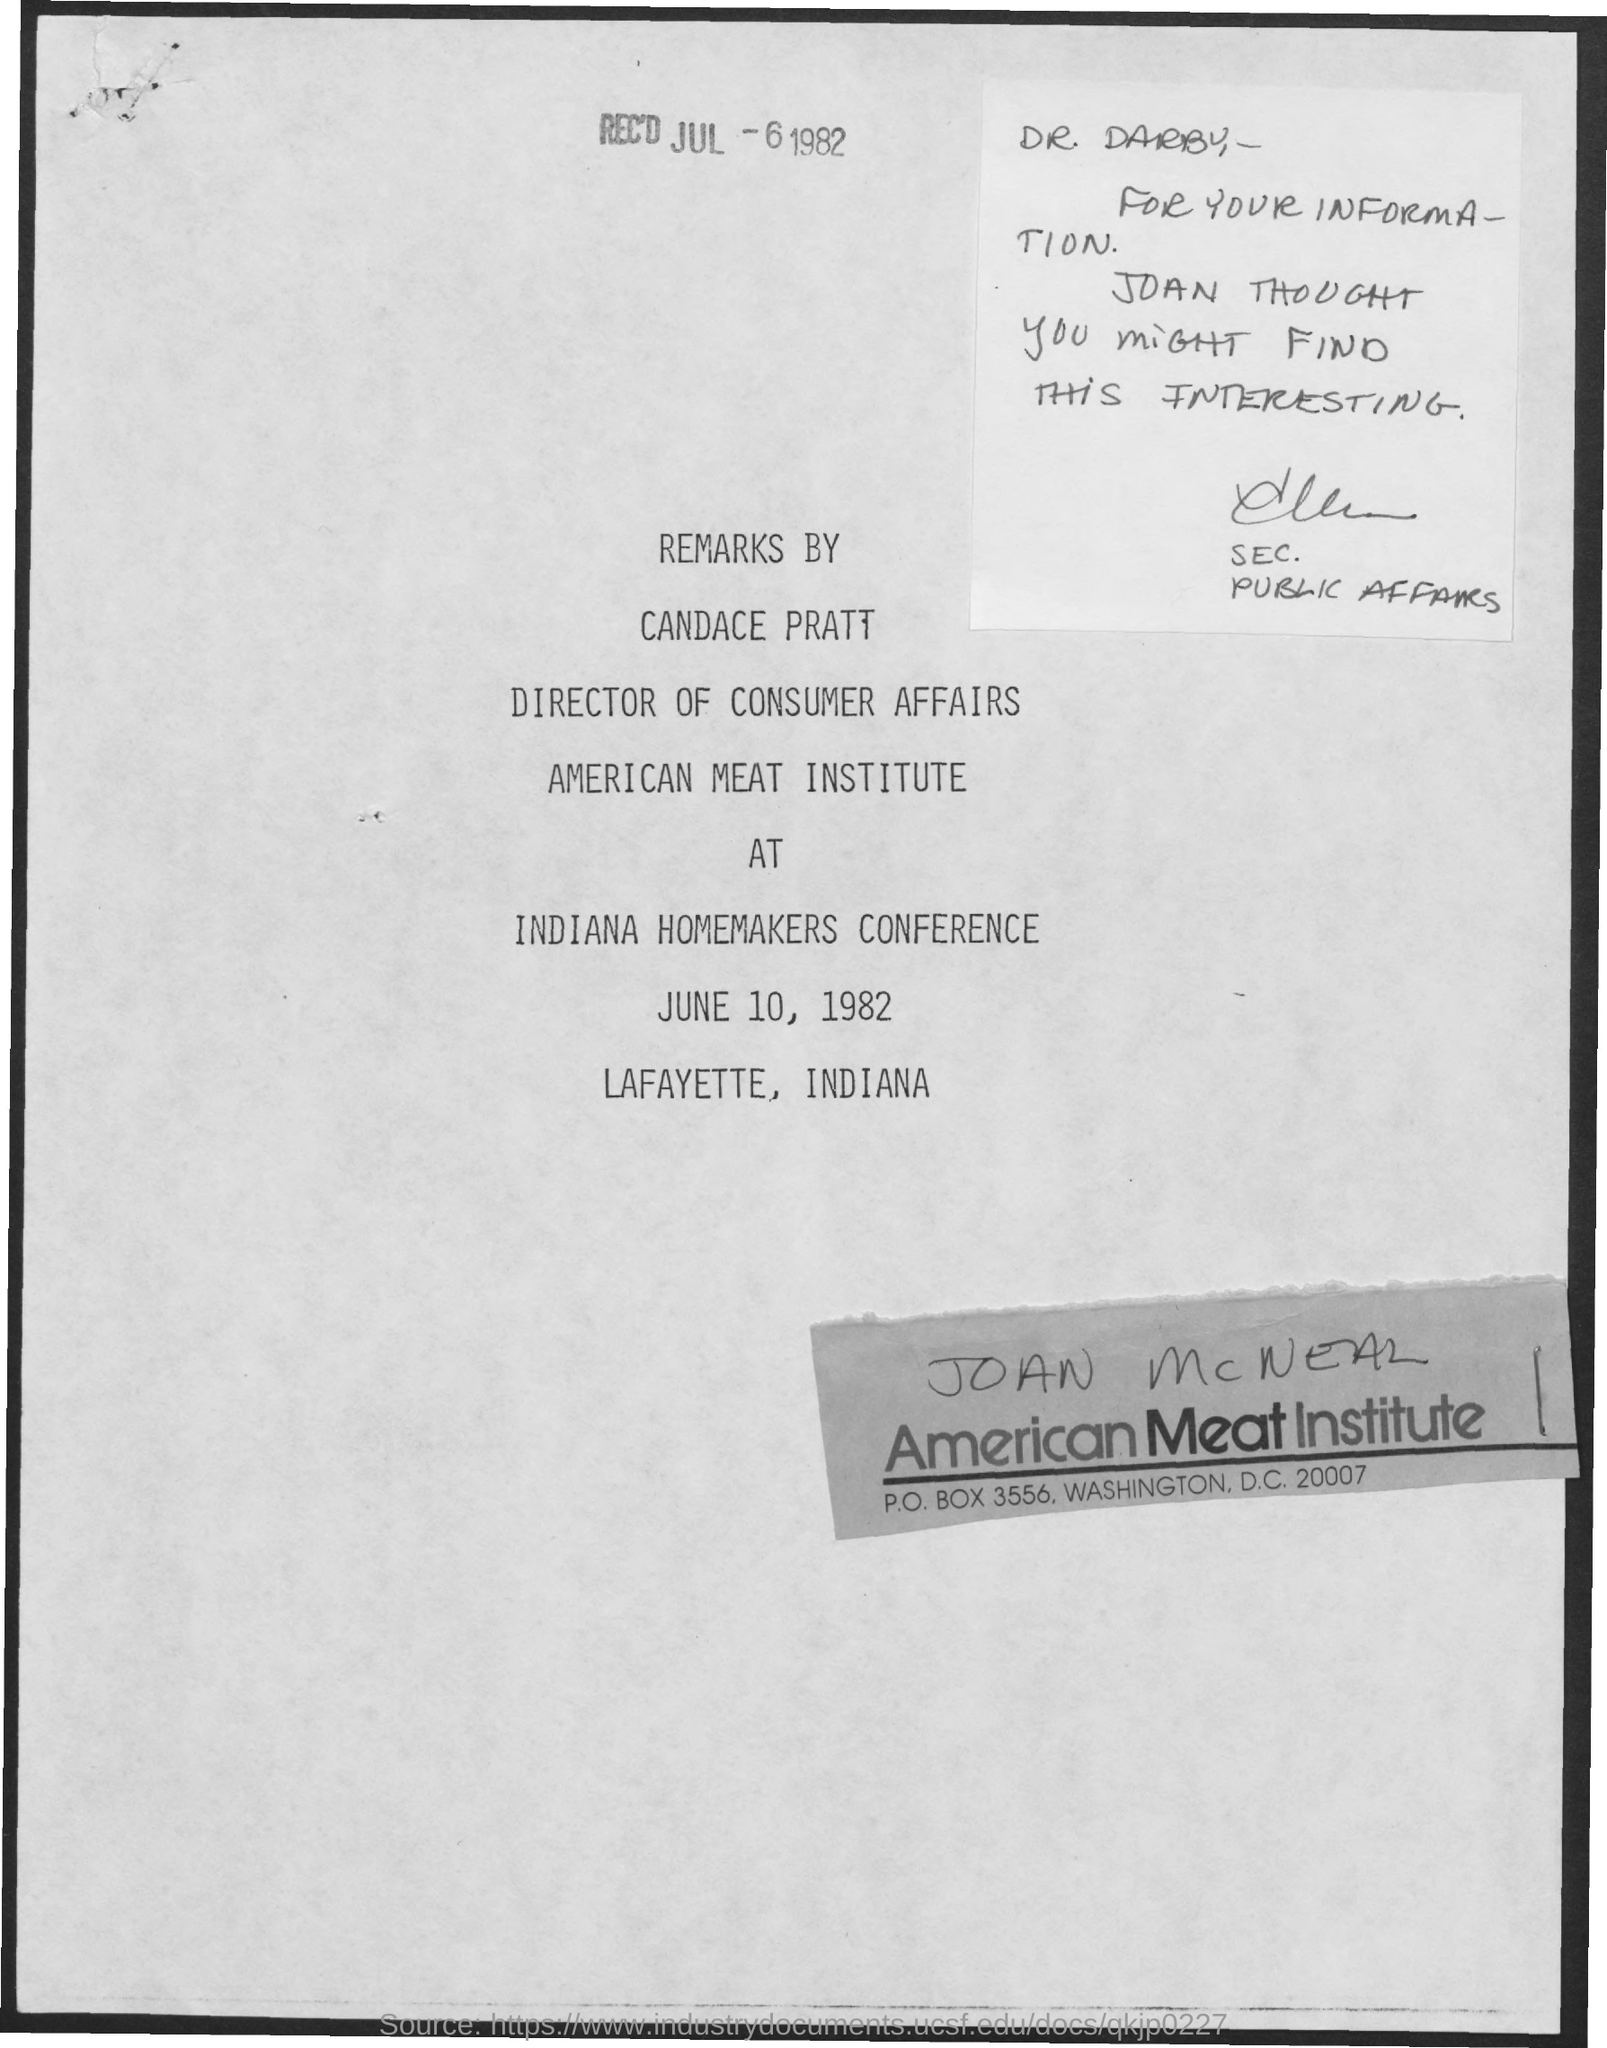Indicate a few pertinent items in this graphic. The remarks are made by Candace Pratt. The note is addressed to Dr. Darby. The conference took place on June 10, 1982. The Indiana Homemakers Conference was where the remarks were given. The date of receipt is July 6, 1982. 